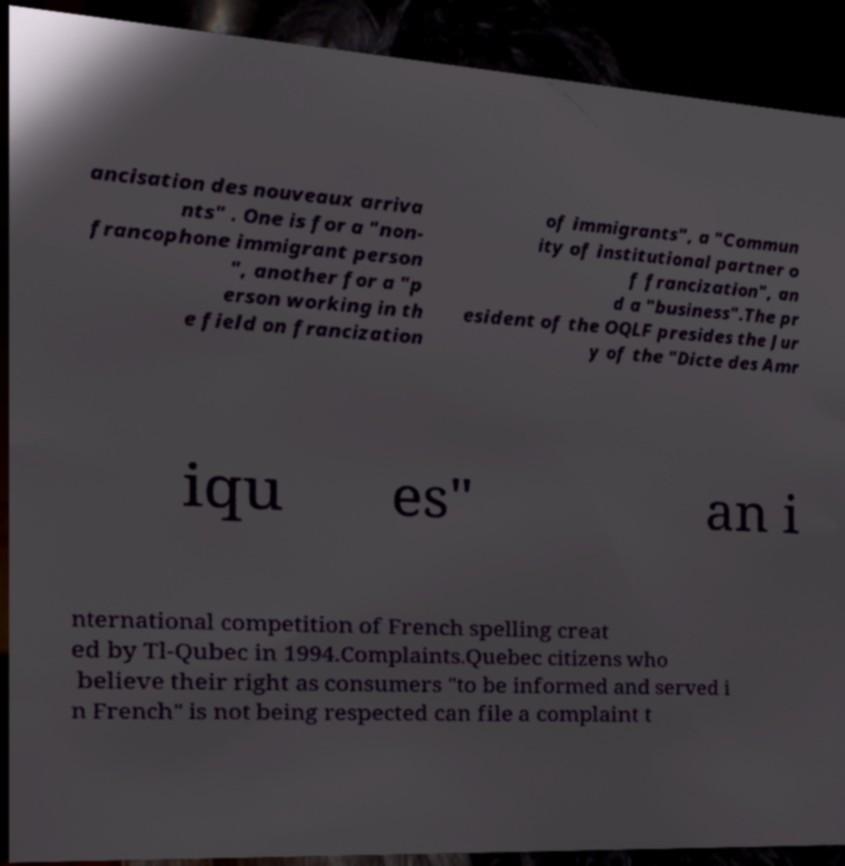Can you read and provide the text displayed in the image?This photo seems to have some interesting text. Can you extract and type it out for me? ancisation des nouveaux arriva nts" . One is for a "non- francophone immigrant person ", another for a "p erson working in th e field on francization of immigrants", a "Commun ity of institutional partner o f francization", an d a "business".The pr esident of the OQLF presides the Jur y of the "Dicte des Amr iqu es" an i nternational competition of French spelling creat ed by Tl-Qubec in 1994.Complaints.Quebec citizens who believe their right as consumers "to be informed and served i n French" is not being respected can file a complaint t 